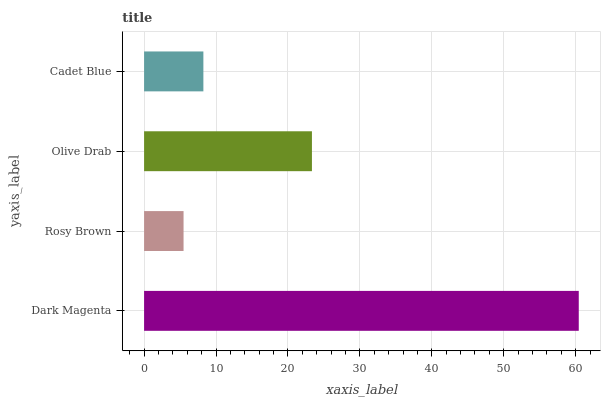Is Rosy Brown the minimum?
Answer yes or no. Yes. Is Dark Magenta the maximum?
Answer yes or no. Yes. Is Olive Drab the minimum?
Answer yes or no. No. Is Olive Drab the maximum?
Answer yes or no. No. Is Olive Drab greater than Rosy Brown?
Answer yes or no. Yes. Is Rosy Brown less than Olive Drab?
Answer yes or no. Yes. Is Rosy Brown greater than Olive Drab?
Answer yes or no. No. Is Olive Drab less than Rosy Brown?
Answer yes or no. No. Is Olive Drab the high median?
Answer yes or no. Yes. Is Cadet Blue the low median?
Answer yes or no. Yes. Is Cadet Blue the high median?
Answer yes or no. No. Is Rosy Brown the low median?
Answer yes or no. No. 